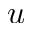Convert formula to latex. <formula><loc_0><loc_0><loc_500><loc_500>u</formula> 